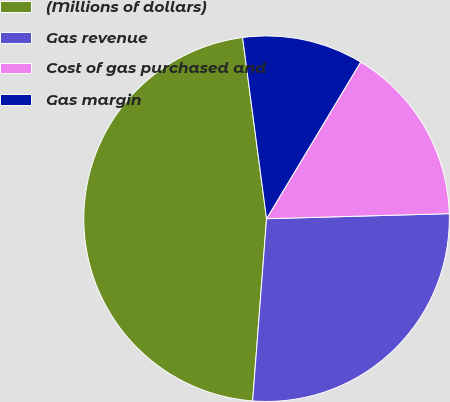Convert chart. <chart><loc_0><loc_0><loc_500><loc_500><pie_chart><fcel>(Millions of dollars)<fcel>Gas revenue<fcel>Cost of gas purchased and<fcel>Gas margin<nl><fcel>46.69%<fcel>26.65%<fcel>15.95%<fcel>10.7%<nl></chart> 